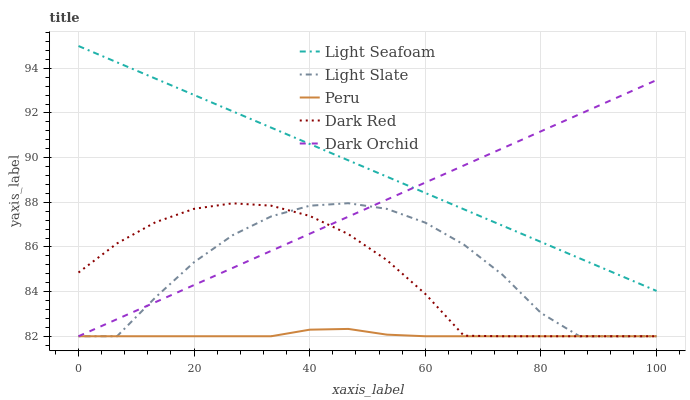Does Peru have the minimum area under the curve?
Answer yes or no. Yes. Does Light Seafoam have the maximum area under the curve?
Answer yes or no. Yes. Does Dark Red have the minimum area under the curve?
Answer yes or no. No. Does Dark Red have the maximum area under the curve?
Answer yes or no. No. Is Light Seafoam the smoothest?
Answer yes or no. Yes. Is Light Slate the roughest?
Answer yes or no. Yes. Is Dark Red the smoothest?
Answer yes or no. No. Is Dark Red the roughest?
Answer yes or no. No. Does Light Slate have the lowest value?
Answer yes or no. Yes. Does Light Seafoam have the lowest value?
Answer yes or no. No. Does Light Seafoam have the highest value?
Answer yes or no. Yes. Does Dark Red have the highest value?
Answer yes or no. No. Is Peru less than Light Seafoam?
Answer yes or no. Yes. Is Light Seafoam greater than Dark Red?
Answer yes or no. Yes. Does Dark Orchid intersect Dark Red?
Answer yes or no. Yes. Is Dark Orchid less than Dark Red?
Answer yes or no. No. Is Dark Orchid greater than Dark Red?
Answer yes or no. No. Does Peru intersect Light Seafoam?
Answer yes or no. No. 